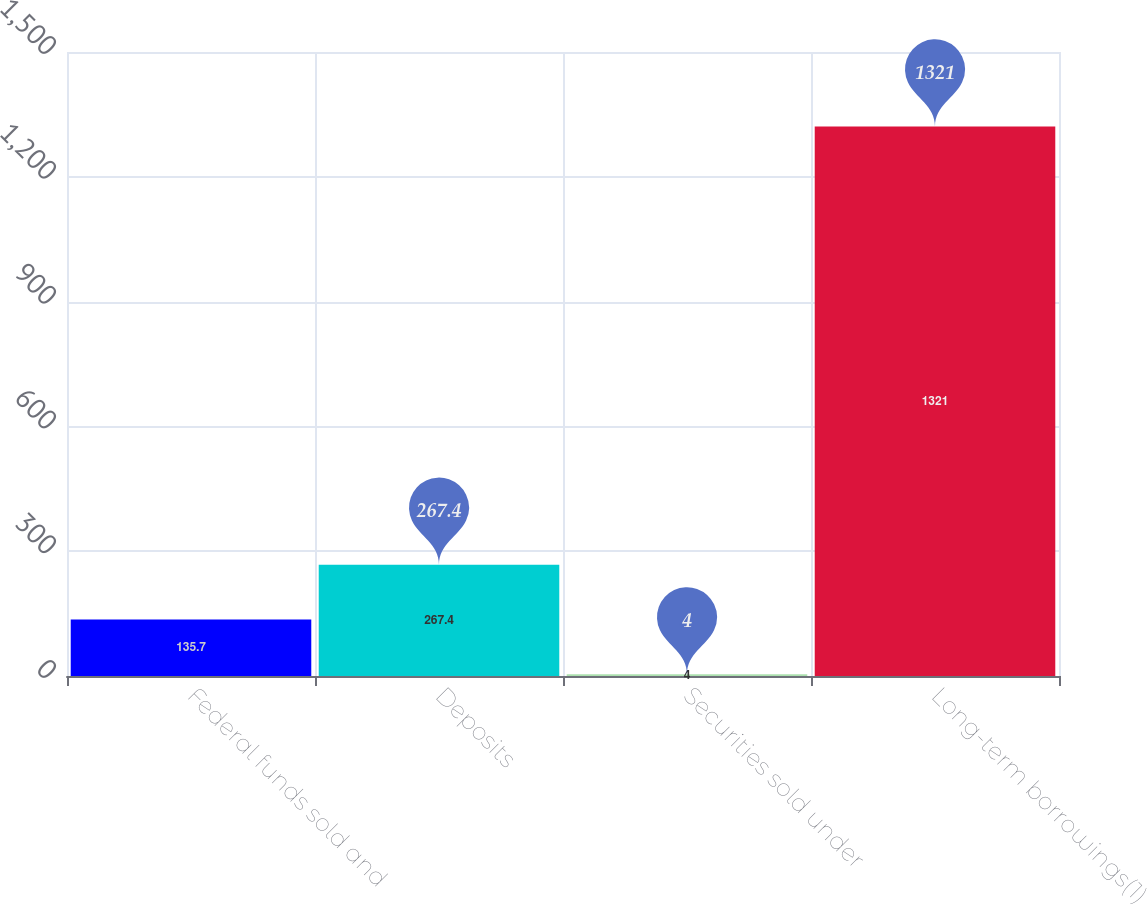Convert chart. <chart><loc_0><loc_0><loc_500><loc_500><bar_chart><fcel>Federal funds sold and<fcel>Deposits<fcel>Securities sold under<fcel>Long-term borrowings(1)<nl><fcel>135.7<fcel>267.4<fcel>4<fcel>1321<nl></chart> 